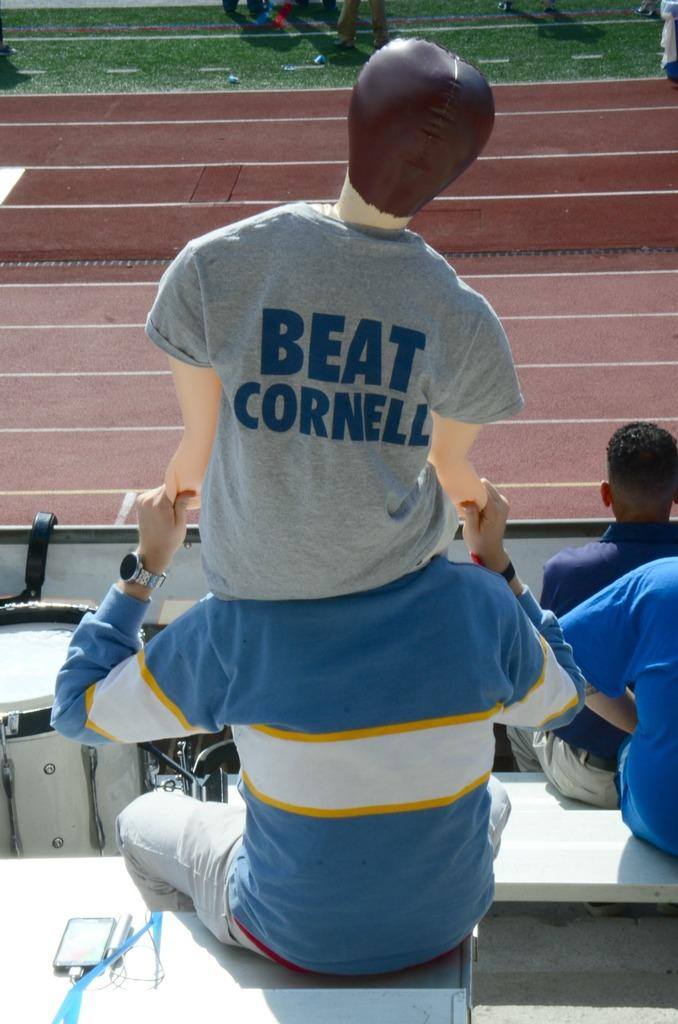<image>
Describe the image concisely. the words beat cornell that is on a shirt 